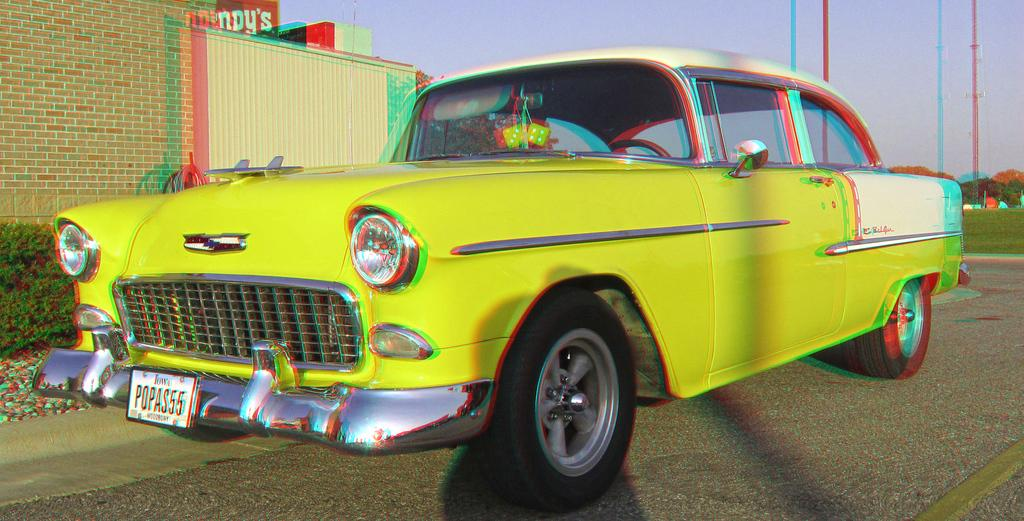<image>
Create a compact narrative representing the image presented. The first few letters of a license plate say "POP." 